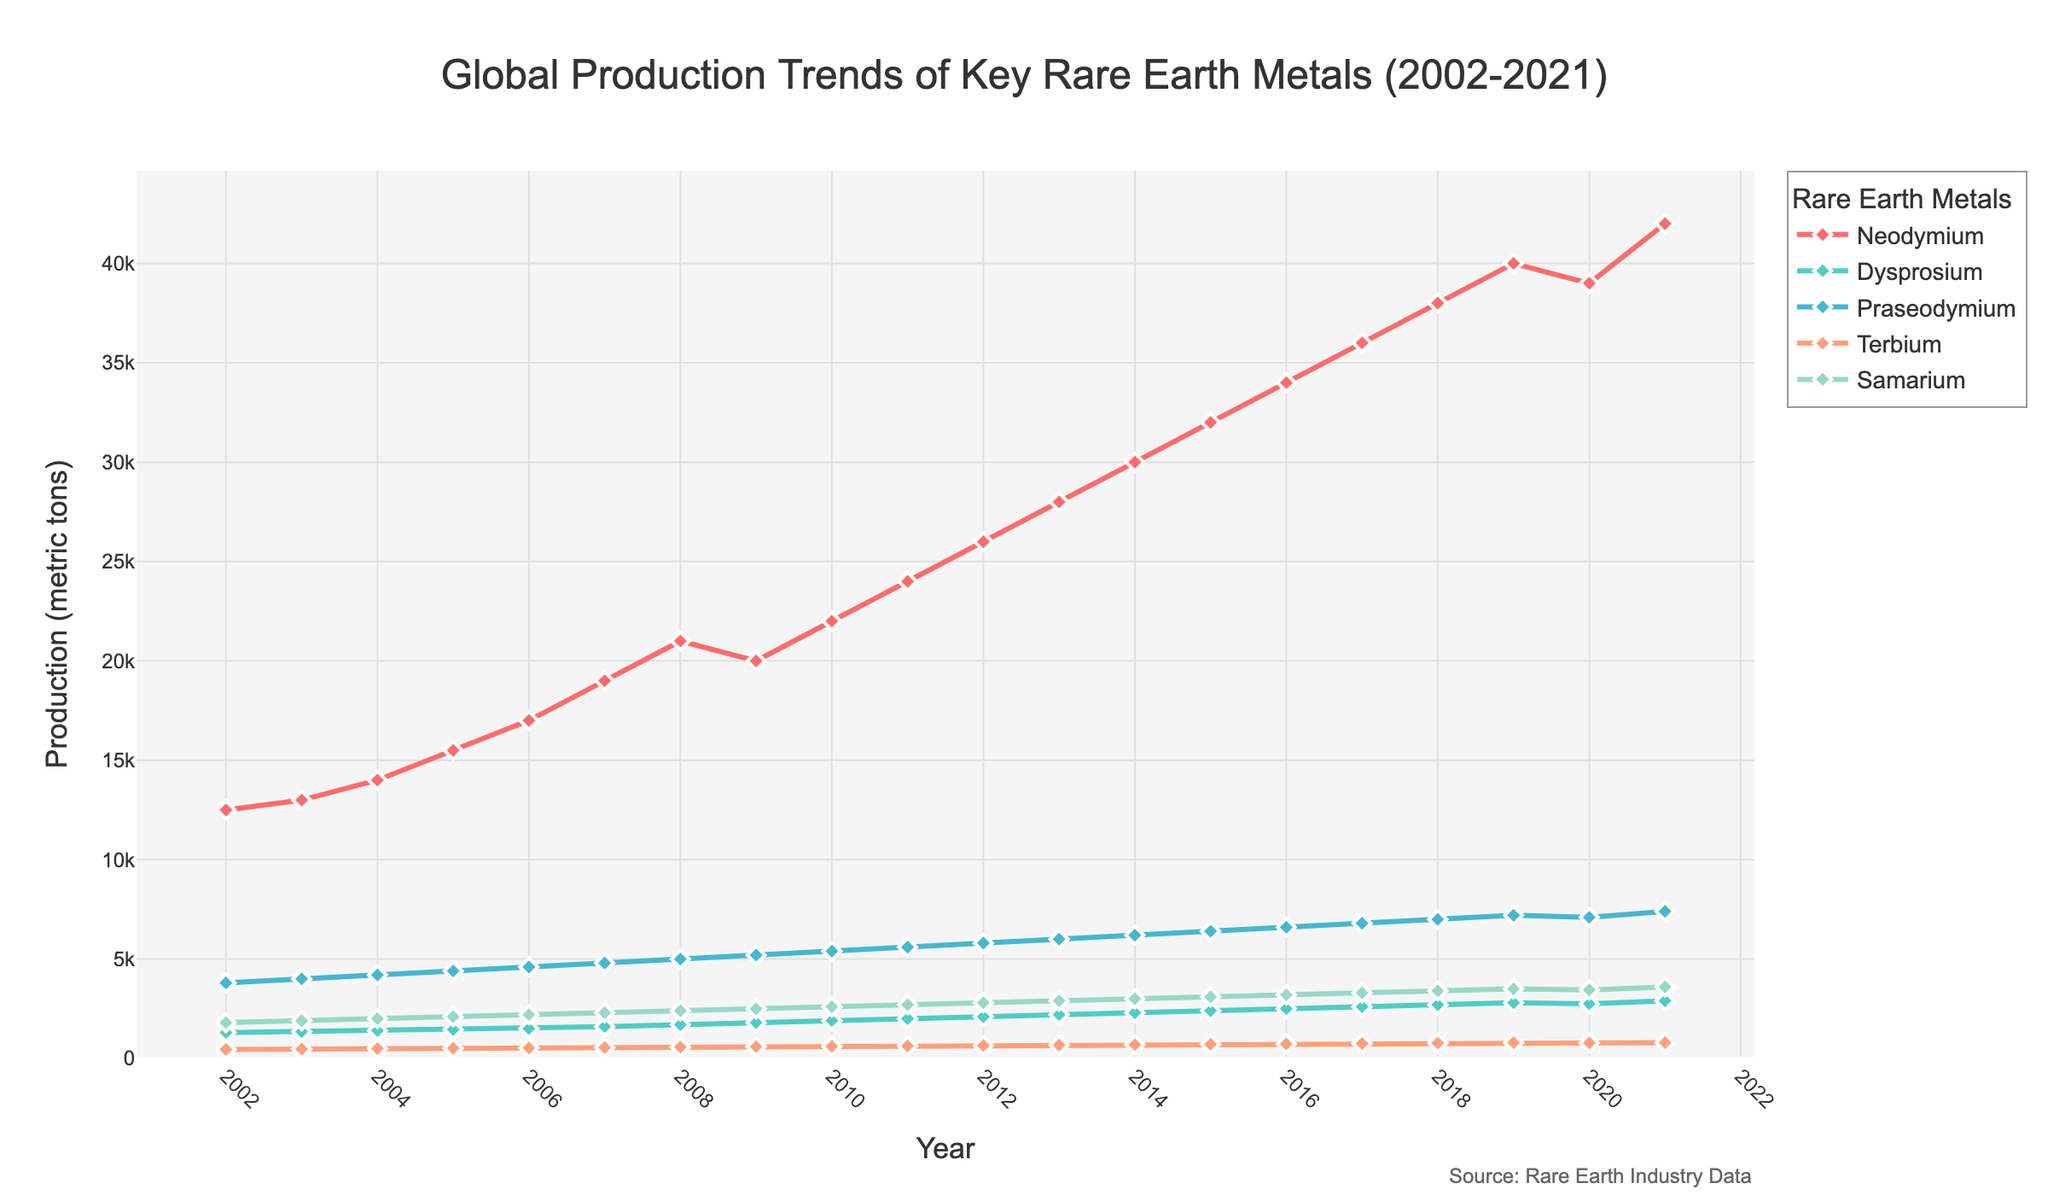Which rare earth metal had the highest production in 2021? To find the answer, look at the data points for each metal in 2021. Neodymium has the highest production level with 42,000 metric tons.
Answer: Neodymium What were the production trends of Neodymium and Dysprosium between 2010 and 2020? From the figure, compare the production values for Neodymium and Dysprosium for the years 2010 to 2020. Neodymium increased from 22,000 to 39,000 metric tons while Dysprosium increased from 1,900 to 2,750 metric tons.
Answer: Both increased, Neodymium more than Dysprosium Which year had the lowest production for Samarium, and what was the value? Identify the lowest point on the Samarium line in the figure. The lowest production was in 2002, with 1,800 metric tons.
Answer: 2002, 1,800 metric tons Across the span from 2002 to 2021, did the production of Terbium show an upward or downward trend? Examine the starting and ending points of Terbium’s line. It steadily increased from 450 metric tons in 2002 to 800 metric tons in 2021.
Answer: Upward Between 2015 and 2018, which metal showed the greatest increase in production? Calculate the difference in production for each metal between 2015 and 2018, then compare these differences. Neodymium increased by 6,000 metric tons, the greatest among all.
Answer: Neodymium What is the average production of Praseodymium over the last five years (2017-2021)? Add the annual production values for Praseodymium from 2017 to 2021 and divide by 5. (6,800 + 7,000 + 7,200 + 7,100 + 7,400) / 5 = 7,100 metric tons.
Answer: 7,100 metric tons By how much did the production of Neodymium increase from the year 2002 to 2011? Subtract the 2002 production value of Neodymium from the 2011 value. 24,000 - 12,500 = 11,500 metric tons.
Answer: 11,500 metric tons Compare the production levels of Samarium and Terbium in 2019. Which one was higher and by how much? Look at the values for both metals in 2019 and subtract the lower from the higher. Samarium was at 3,500 metric tons and Terbium at 790 metric tons. 3,500 - 790 = 2,710 metric tons.
Answer: Samarium, 2,710 metric tons higher 